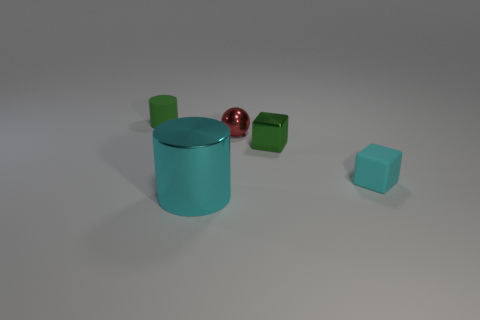Add 4 brown balls. How many objects exist? 9 Subtract all balls. How many objects are left? 4 Subtract all big brown metal cubes. Subtract all small cyan things. How many objects are left? 4 Add 3 large cylinders. How many large cylinders are left? 4 Add 4 cyan shiny cylinders. How many cyan shiny cylinders exist? 5 Subtract 0 purple cubes. How many objects are left? 5 